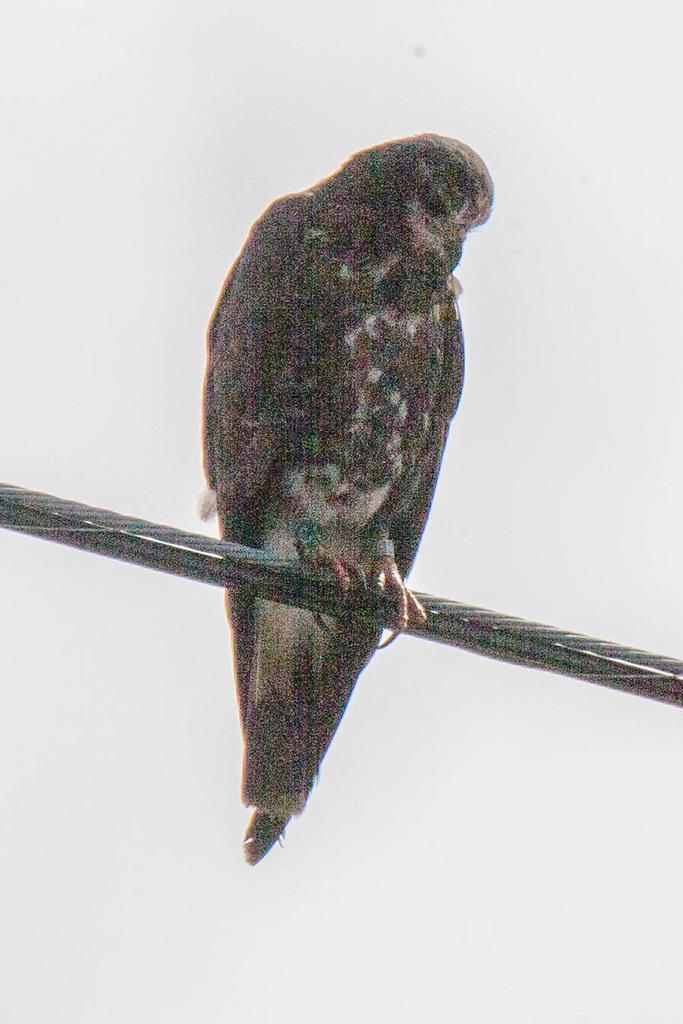What type of animal can be seen in the image? There is a bird in the image. Where is the bird located? The bird is sitting on wires. What color is the background of the image? The background of the image is white. What country does the stranger in the image come from? There is no stranger present in the image, only a bird sitting on wires. 